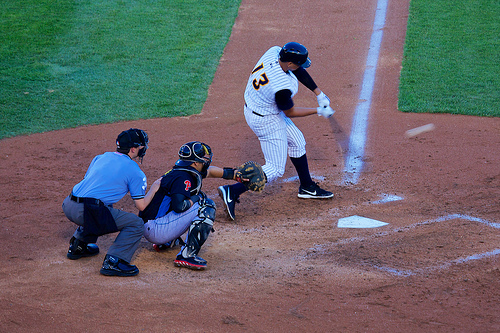Who is wearing a helmet? The player at bat, who is currently ready to strike the ball, is wearing a helmet. 